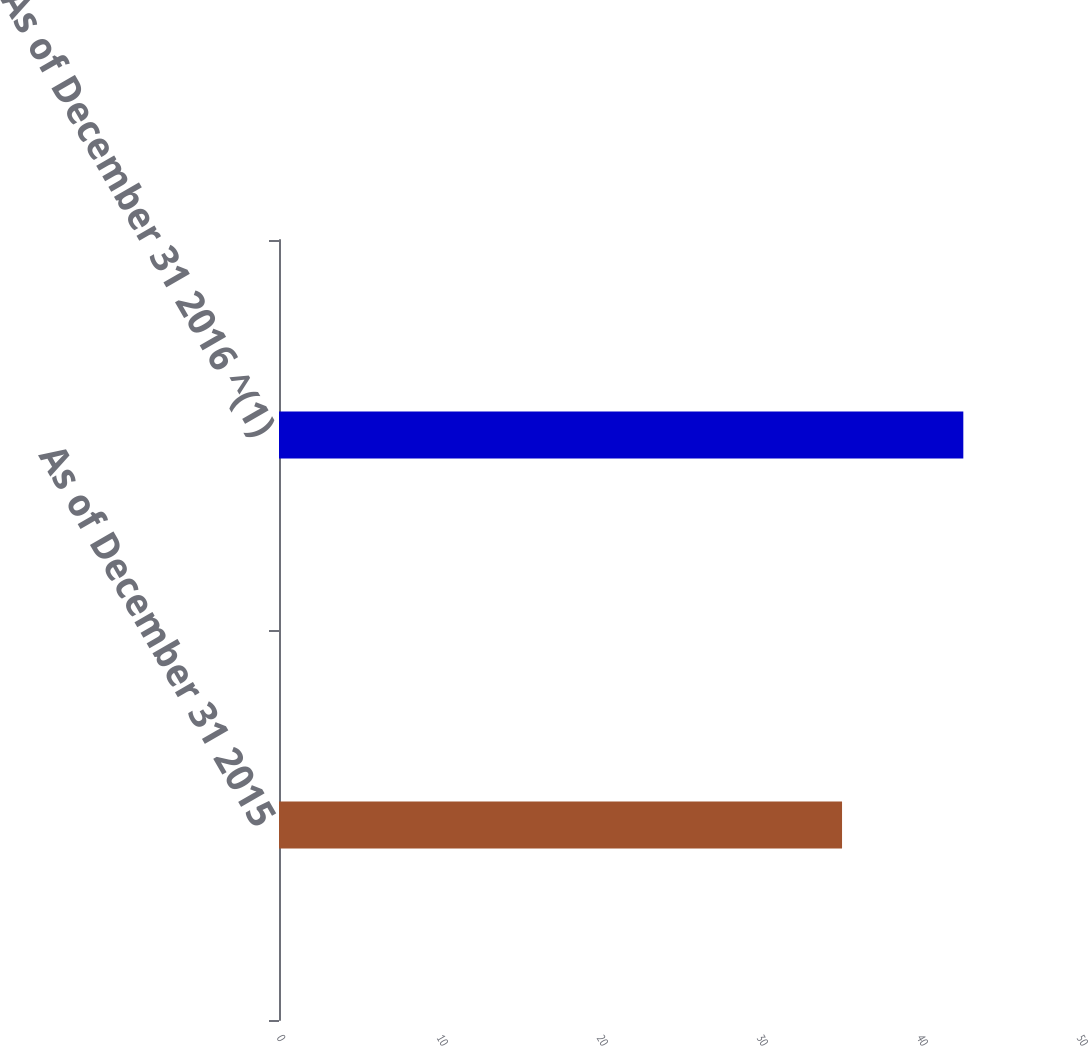<chart> <loc_0><loc_0><loc_500><loc_500><bar_chart><fcel>As of December 31 2015<fcel>As of December 31 2016 ^(1)<nl><fcel>35.19<fcel>42.77<nl></chart> 